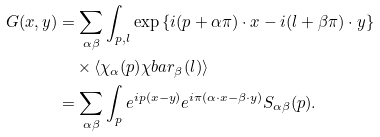Convert formula to latex. <formula><loc_0><loc_0><loc_500><loc_500>G ( x , y ) & = \sum _ { \alpha \beta } \int _ { p , l } \exp { \left \{ i ( p + \alpha \pi ) \cdot x - i ( l + \beta \pi ) \cdot y \right \} } \\ & \quad \times \langle \chi _ { \alpha } ( p ) \chi b a r _ { \beta } ( l ) \rangle \\ & = \sum _ { \alpha \beta } \int _ { p } e ^ { i p ( x - y ) } e ^ { i \pi ( \alpha \cdot x - \beta \cdot y ) } S _ { \alpha \beta } ( p ) .</formula> 